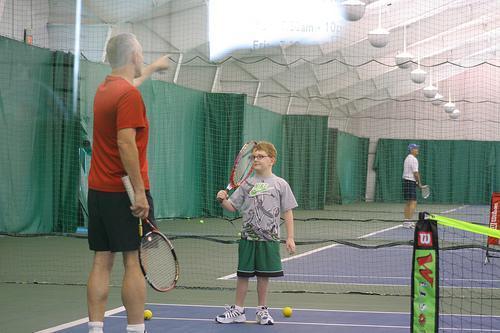How many players?
Give a very brief answer. 3. 